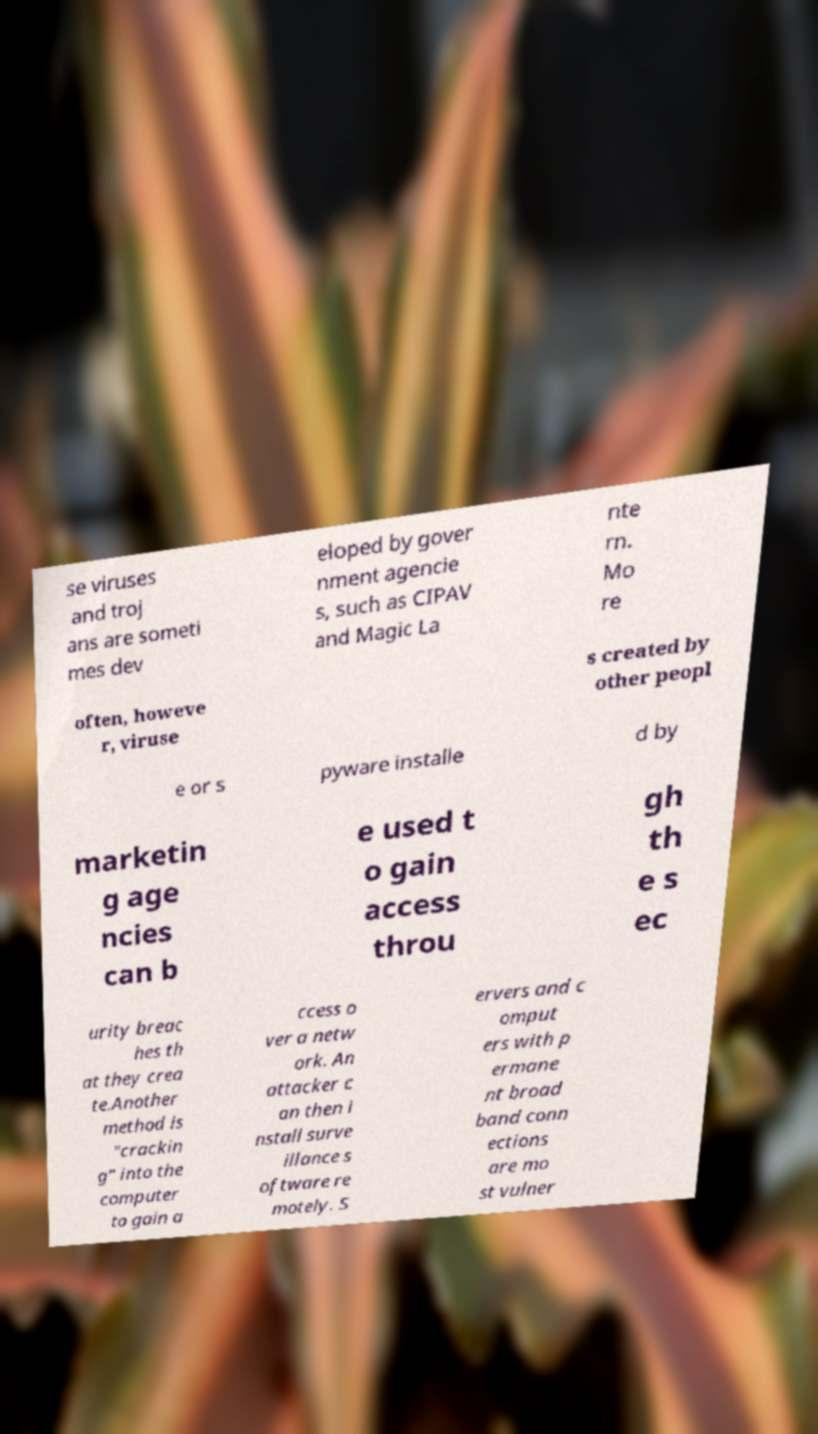Could you assist in decoding the text presented in this image and type it out clearly? se viruses and troj ans are someti mes dev eloped by gover nment agencie s, such as CIPAV and Magic La nte rn. Mo re often, howeve r, viruse s created by other peopl e or s pyware installe d by marketin g age ncies can b e used t o gain access throu gh th e s ec urity breac hes th at they crea te.Another method is "crackin g" into the computer to gain a ccess o ver a netw ork. An attacker c an then i nstall surve illance s oftware re motely. S ervers and c omput ers with p ermane nt broad band conn ections are mo st vulner 